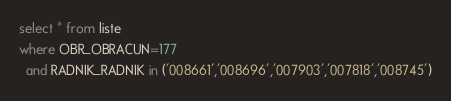<code> <loc_0><loc_0><loc_500><loc_500><_SQL_>select * from liste
where OBR_OBRACUN=177
  and RADNIK_RADNIK in ('008661','008696','007903','007818','008745')
</code> 